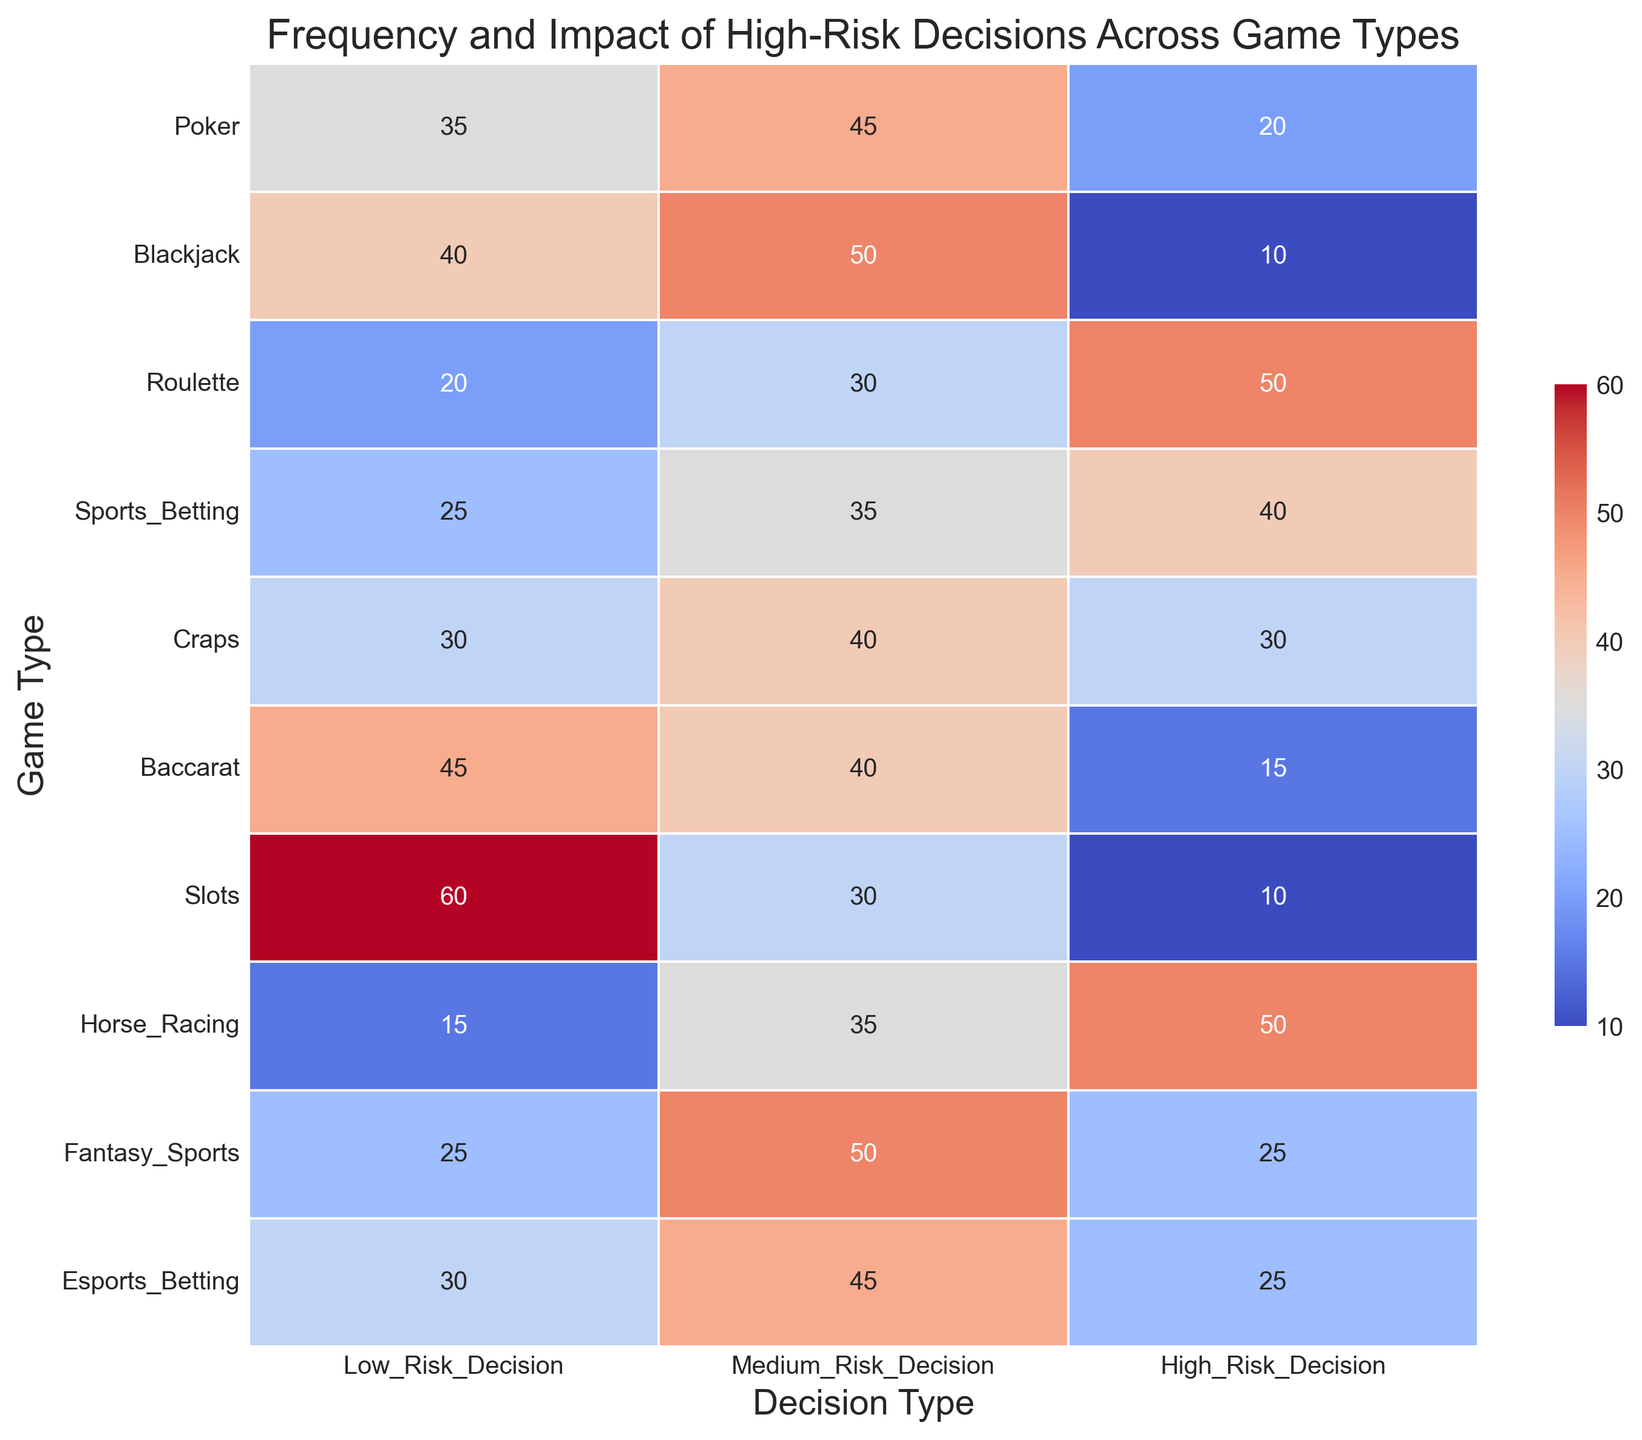Which game type has the highest frequency of high-risk decisions? By looking at the heatmap's cell values under the "High_Risk_Decision" column, locate the highest value and identify the corresponding game type. The highest value in the "High_Risk_Decision" column is 50, and it appears for both Roulette and Horse Racing.
Answer: Roulette and Horse Racing Which decision type is most frequent in Poker? Locate the row corresponding to Poker, then identify the highest value among Low_Risk_Decision, Medium_Risk_Decision, and High_Risk_Decision within that row. The highest value in Poker's row is 45, which corresponds to Medium_Risk_Decision.
Answer: Medium_Risk_Decision What is the sum of high-risk decisions across all game types? Sum up all the values under the "High_Risk_Decision" column: 20 (Poker) + 10 (Blackjack) + 50 (Roulette) + 40 (Sports_Betting) + 30 (Craps) + 15 (Baccarat) + 10 (Slots) + 50 (Horse_Racing) + 25 (Fantasy_Sports) + 25 (Esports_Betting). The total is 20+10+50+40+30+15+10+50+25+25 = 275.
Answer: 275 Which game type has the lowest frequency of low-risk decisions? Identify the smallest value in the "Low_Risk_Decision" column and find the corresponding game type. The smallest value in the "Low_Risk_Decision" column is 15, corresponding to Horse Racing.
Answer: Horse Racing Are there any game types where medium-risk decisions are the most frequent category? If so, which ones? For each game type, compare the values across Low_Risk_Decision, Medium_Risk_Decision, and High_Risk_Decision. The game types where Medium_Risk_Decision is the highest value are Poker (45), Blackjack (50), Fantasy Sports (50), and Esports Betting (45).
Answer: Poker, Blackjack, Fantasy Sports, Esports Betting Which decision type overall has the most frequent decisions across all games? Sum the values for Low_Risk_Decision, Medium_Risk_Decision, and High_Risk_Decision columns independently and compare the sums. The sums are: Low_Risk_Decision (35+40+20+25+30+45+60+15+25+30 = 325), Medium_Risk_Decision (45+50+30+35+40+40+30+35+50+45 = 400), High_Risk_Decision (20+10+50+40+30+15+10+50+25+25 = 275). Medium_Risk_Decision has the highest sum.
Answer: Medium_Risk_Decision Is there a game type where the frequency of low-risk decisions is equal to the frequency of medium-risk decisions? For each game type, compare the Low_Risk_Decision and Medium_Risk_Decision values. Craps has equal values of 40 for both decision types.
Answer: Craps What is the difference in frequency of high-risk decisions between Roulette and Blackjack? Subtract the frequency of high-risk decisions in Blackjack from that in Roulette. The values are 50 (Roulette) and 10 (Blackjack). The difference is 50 - 10.
Answer: 40 Which game type has a similar frequency of high-risk decisions to that of low-risk decisions in Blackjack? Find game types where the frequency of high-risk decisions is close to the value of low-risk decisions in Blackjack, which is 40. Both Craps and Fantasy Sports have high-risk decision frequencies of 30 and 35 respectively, which are closer to 40 compared to others.
Answer: Craps, Fantasy Sports 